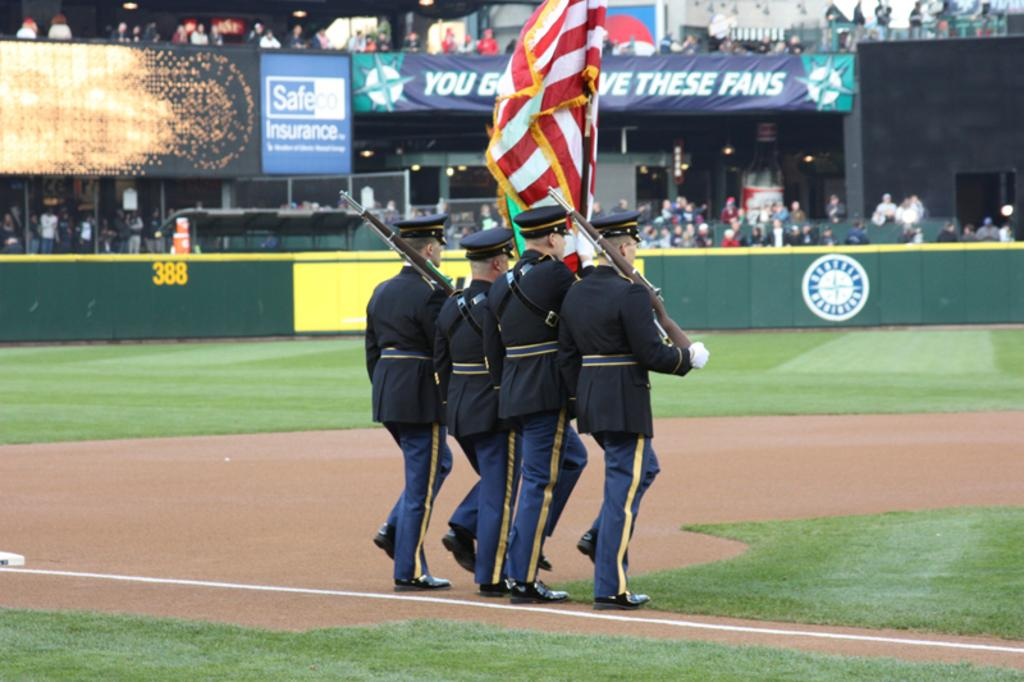<image>
Create a compact narrative representing the image presented. Military people are marching out onto a field with a Safeco Insurance advertisement on it. 